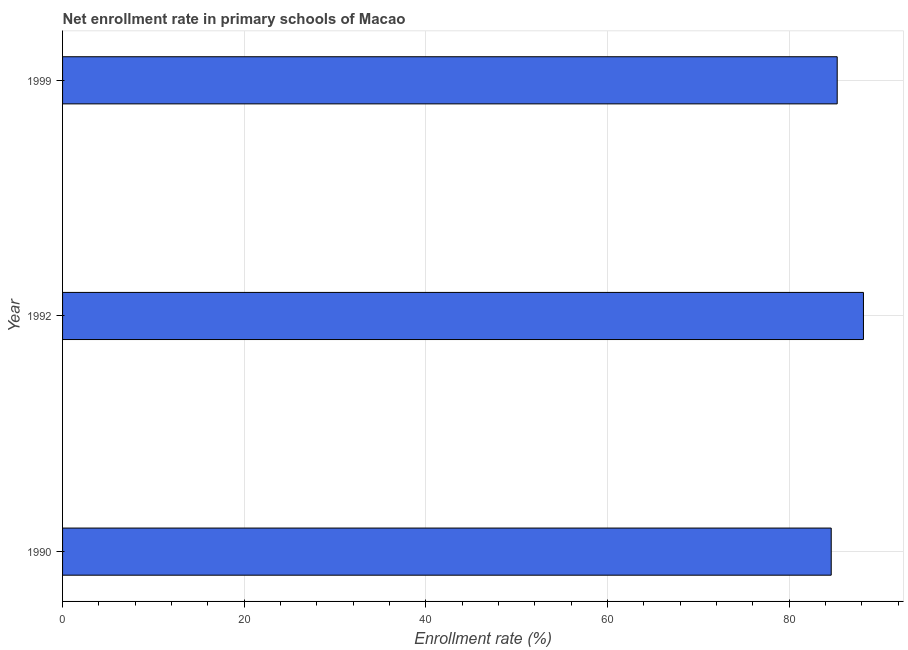Does the graph contain any zero values?
Give a very brief answer. No. Does the graph contain grids?
Make the answer very short. Yes. What is the title of the graph?
Your answer should be compact. Net enrollment rate in primary schools of Macao. What is the label or title of the X-axis?
Your answer should be very brief. Enrollment rate (%). What is the label or title of the Y-axis?
Give a very brief answer. Year. What is the net enrollment rate in primary schools in 1992?
Offer a very short reply. 88.19. Across all years, what is the maximum net enrollment rate in primary schools?
Your response must be concise. 88.19. Across all years, what is the minimum net enrollment rate in primary schools?
Offer a terse response. 84.64. What is the sum of the net enrollment rate in primary schools?
Make the answer very short. 258.12. What is the difference between the net enrollment rate in primary schools in 1990 and 1992?
Provide a succinct answer. -3.55. What is the average net enrollment rate in primary schools per year?
Provide a succinct answer. 86.04. What is the median net enrollment rate in primary schools?
Provide a short and direct response. 85.3. What is the ratio of the net enrollment rate in primary schools in 1990 to that in 1992?
Provide a succinct answer. 0.96. Is the difference between the net enrollment rate in primary schools in 1990 and 1992 greater than the difference between any two years?
Provide a succinct answer. Yes. What is the difference between the highest and the second highest net enrollment rate in primary schools?
Provide a succinct answer. 2.89. What is the difference between the highest and the lowest net enrollment rate in primary schools?
Keep it short and to the point. 3.55. In how many years, is the net enrollment rate in primary schools greater than the average net enrollment rate in primary schools taken over all years?
Give a very brief answer. 1. How many bars are there?
Ensure brevity in your answer.  3. Are all the bars in the graph horizontal?
Offer a terse response. Yes. How many years are there in the graph?
Offer a very short reply. 3. What is the difference between two consecutive major ticks on the X-axis?
Ensure brevity in your answer.  20. What is the Enrollment rate (%) of 1990?
Keep it short and to the point. 84.64. What is the Enrollment rate (%) in 1992?
Make the answer very short. 88.19. What is the Enrollment rate (%) in 1999?
Your response must be concise. 85.3. What is the difference between the Enrollment rate (%) in 1990 and 1992?
Provide a succinct answer. -3.55. What is the difference between the Enrollment rate (%) in 1990 and 1999?
Your answer should be very brief. -0.66. What is the difference between the Enrollment rate (%) in 1992 and 1999?
Make the answer very short. 2.89. What is the ratio of the Enrollment rate (%) in 1990 to that in 1992?
Provide a short and direct response. 0.96. What is the ratio of the Enrollment rate (%) in 1990 to that in 1999?
Keep it short and to the point. 0.99. What is the ratio of the Enrollment rate (%) in 1992 to that in 1999?
Make the answer very short. 1.03. 